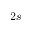<formula> <loc_0><loc_0><loc_500><loc_500>2 s</formula> 